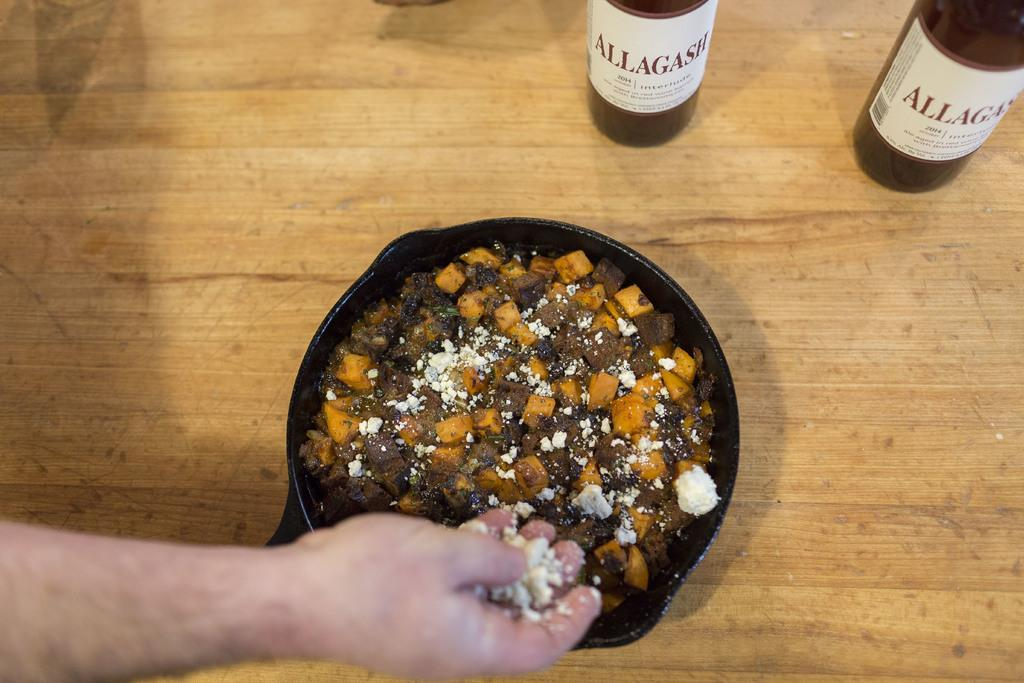<image>
Share a concise interpretation of the image provided. Plate with carrots and meat mixed together with a bottle of Allagash. 